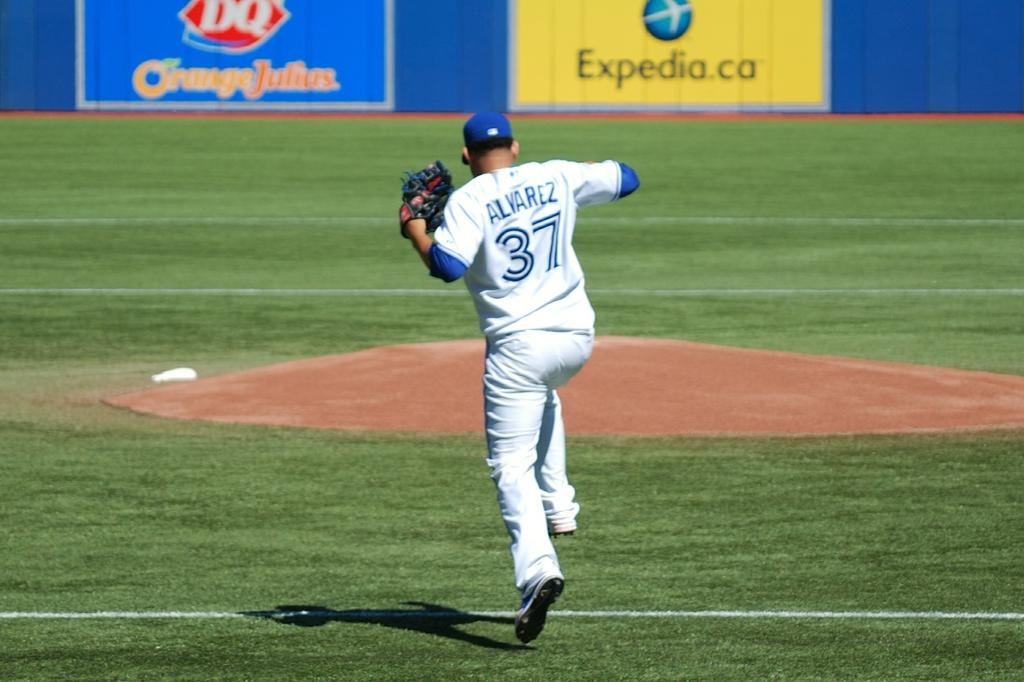<image>
Give a short and clear explanation of the subsequent image. A baseball player named Alvarez hopping over a baseline. 